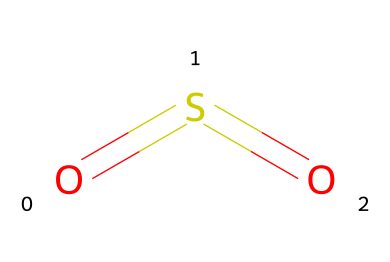How many atoms are present in this molecule? The molecular structure represented by the SMILES shows one sulfur atom (S) and two oxygen atoms (O). Thus, the total number of atoms is 3.
Answer: 3 What is the name of this chemical compound? The molecular structure corresponds to sulfur dioxide, which is commonly known as SO2. This name is derived from the elements present in the formula.
Answer: sulfur dioxide How many double bonds are in this chemical structure? The SMILES notation O=S=O denotes the presence of two double bonds involving the sulfur and oxygen atoms. Each double bond is represented by the "=" symbol.
Answer: 2 What type of bonding is present between the sulfur and oxygen in this molecule? The "=" symbol indicates double bonding between sulfur and oxygen, which means there are covalent bonds formed due to the sharing of electrons.
Answer: covalent Is this compound considered a greenhouse gas? Sulfur dioxide, as represented in the molecular structure, is recognized for its role in contributing to atmospheric phenomena, including being a greenhouse gas.
Answer: yes What is the hybridization of the sulfur atom in this molecule? The sulfur in sulfur dioxide has a hybridization of sp, as it forms two double bonds with the oxygen atoms, leading to a linear geometry around the sulfur atom.
Answer: sp What is a primary industrial source of sulfur dioxide? One of the main industrial sources of sulfur dioxide is the combustion of fossil fuels, which often occurs in power generation and various manufacturing processes.
Answer: combustion 